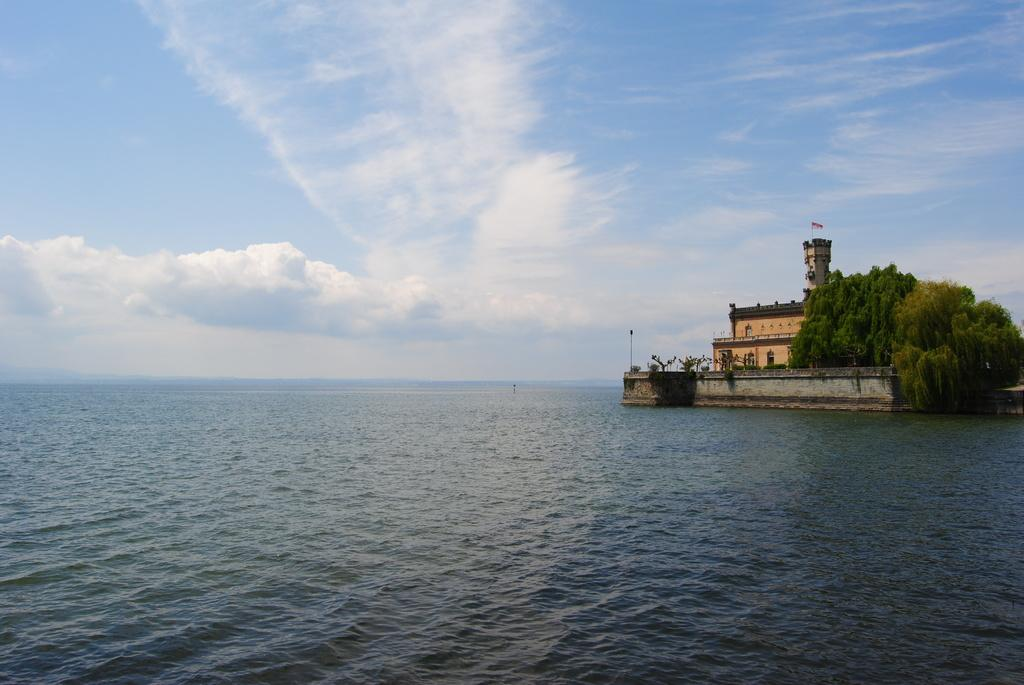What type of structure is present in the image? There is a building in the image. What other natural elements can be seen in the image? There are trees and water visible in the image. What is visible in the background of the image? There are clouds in the background of the image. What type of guitar is being washed in the water in the image? There is no guitar present in the image, nor is there any indication of washing. 